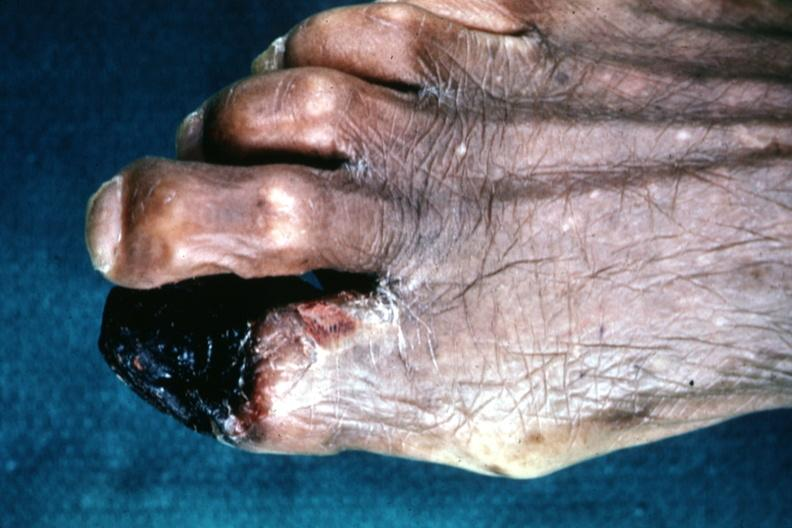re hours present?
Answer the question using a single word or phrase. No 